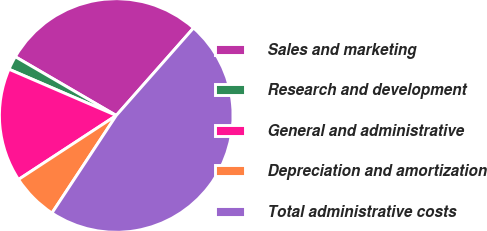<chart> <loc_0><loc_0><loc_500><loc_500><pie_chart><fcel>Sales and marketing<fcel>Research and development<fcel>General and administrative<fcel>Depreciation and amortization<fcel>Total administrative costs<nl><fcel>28.12%<fcel>1.91%<fcel>15.71%<fcel>6.5%<fcel>47.76%<nl></chart> 